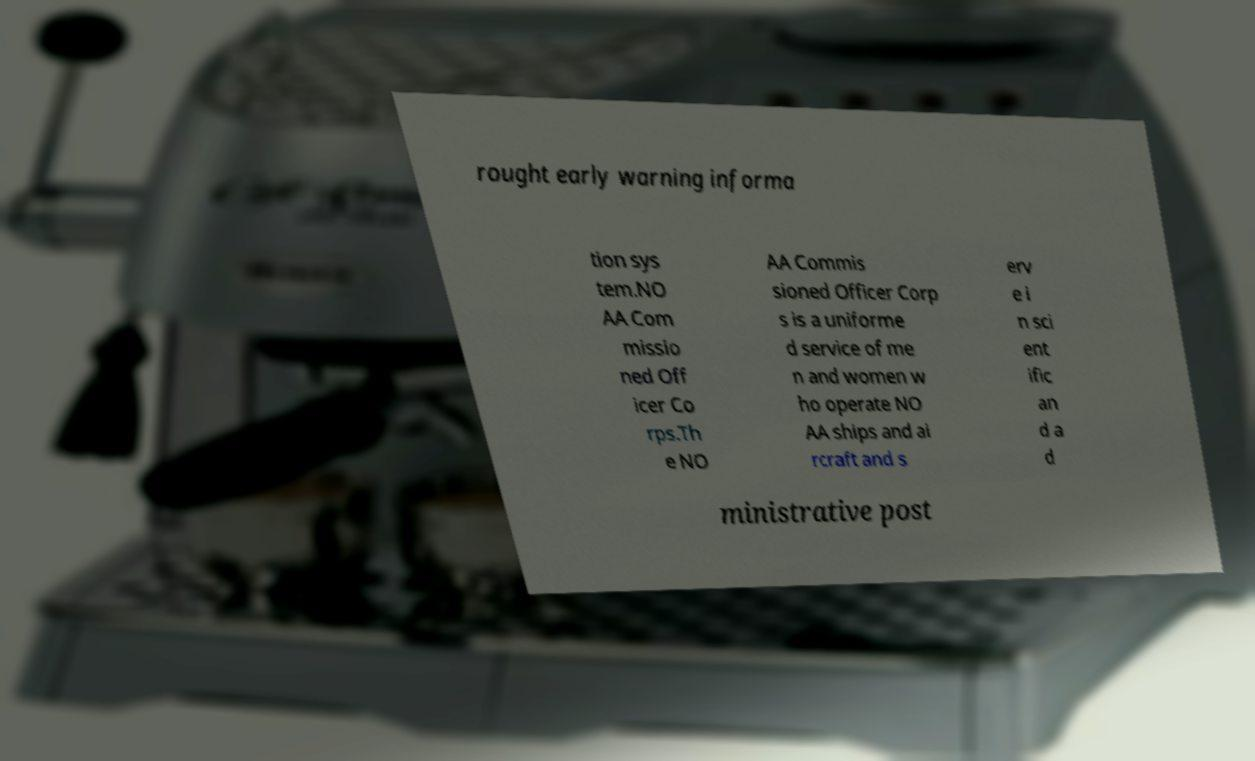What messages or text are displayed in this image? I need them in a readable, typed format. rought early warning informa tion sys tem.NO AA Com missio ned Off icer Co rps.Th e NO AA Commis sioned Officer Corp s is a uniforme d service of me n and women w ho operate NO AA ships and ai rcraft and s erv e i n sci ent ific an d a d ministrative post 